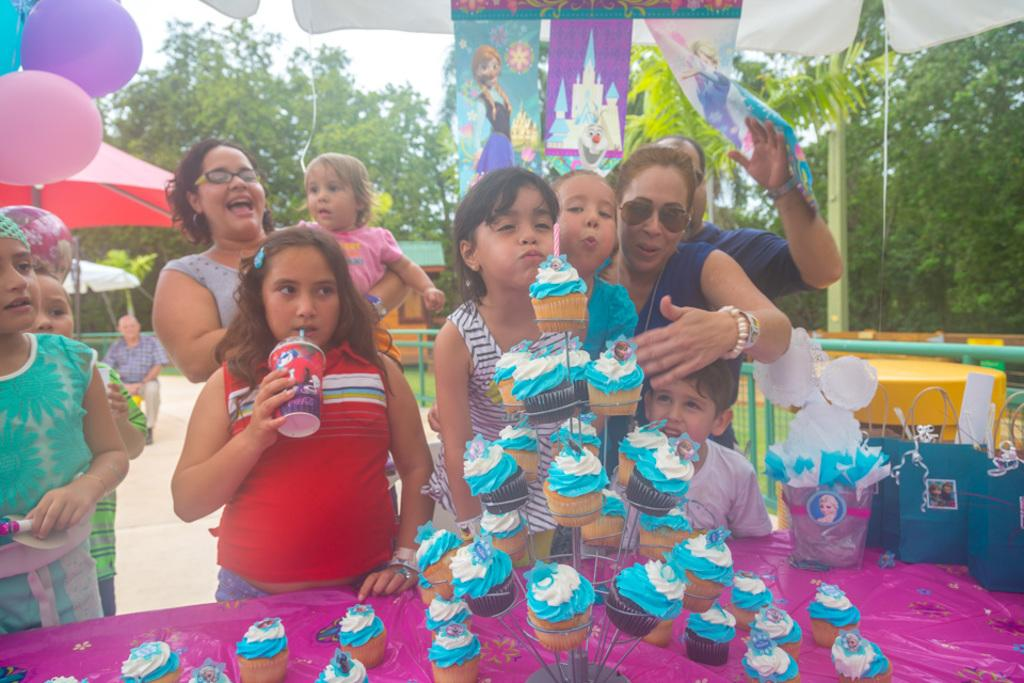What can be seen in the image involving people? There are people standing in the image. What items are being carried by the people? There are carry bags in the image. What type of food is visible in the image? There are cupcakes in the image. What can be seen in the background of the image? There are balloons, trees, and shades in the background of the image. What scientific experiment is being conducted in the image? There is no scientific experiment being conducted in the image. How does the income of the people in the image affect the presence of cupcakes? The income of the people in the image is not mentioned, and therefore it cannot be determined how it affects the presence of cupcakes. 